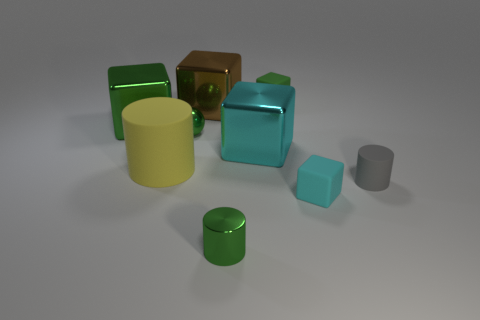What number of other objects are there of the same material as the small green cylinder?
Offer a very short reply. 4. Is the metallic sphere the same color as the small metallic cylinder?
Your answer should be compact. Yes. Is the material of the big yellow thing the same as the tiny green cube?
Your answer should be very brief. Yes. What is the shape of the large green thing?
Your response must be concise. Cube. There is a cyan cube that is right of the green thing that is on the right side of the green cylinder; what number of cyan matte blocks are left of it?
Provide a short and direct response. 0. There is another small object that is the same shape as the green rubber object; what color is it?
Your answer should be compact. Cyan. There is a shiny thing that is to the left of the tiny metal thing behind the small block in front of the tiny ball; what shape is it?
Your answer should be compact. Cube. What is the size of the object that is both on the left side of the small cyan thing and in front of the small gray cylinder?
Offer a very short reply. Small. Are there fewer rubber cubes than large green balls?
Provide a succinct answer. No. What size is the green cube that is behind the large green shiny block?
Offer a terse response. Small. 